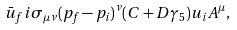<formula> <loc_0><loc_0><loc_500><loc_500>\bar { u } _ { f } i \sigma _ { \mu \nu } ( p _ { f } - p _ { i } ) ^ { \nu } ( C + D \gamma _ { 5 } ) u _ { i } A ^ { \mu } ,</formula> 